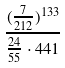Convert formula to latex. <formula><loc_0><loc_0><loc_500><loc_500>\frac { ( \frac { 7 } { 2 1 2 } ) ^ { 1 3 3 } } { \frac { 2 4 } { 5 5 } \cdot 4 4 1 }</formula> 